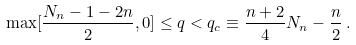<formula> <loc_0><loc_0><loc_500><loc_500>\max [ \frac { N _ { n } - 1 - 2 n } { 2 } , 0 ] \leq q < q _ { c } \equiv \frac { n + 2 } { 4 } N _ { n } - \frac { n } { 2 } \, .</formula> 